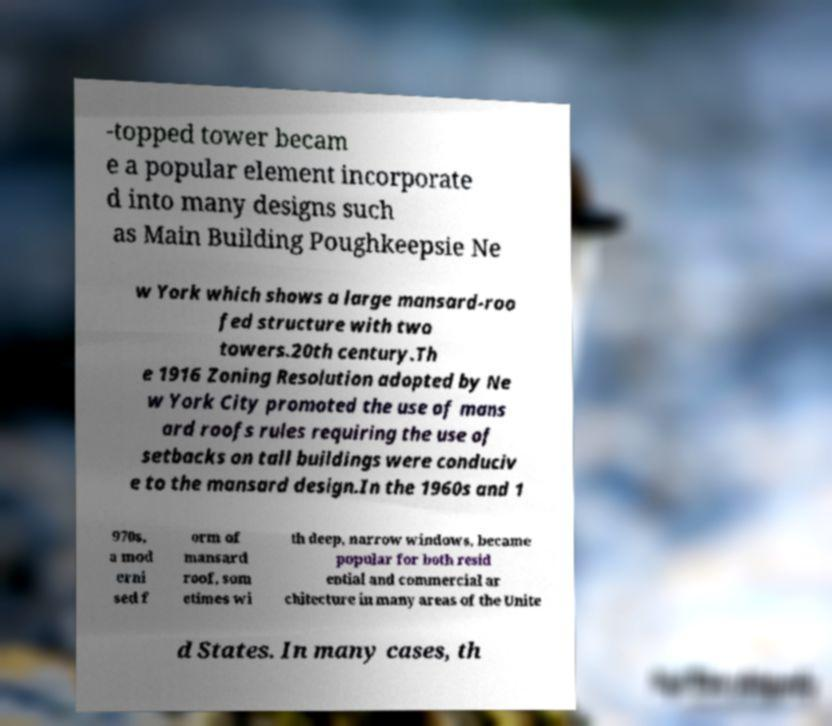Can you accurately transcribe the text from the provided image for me? -topped tower becam e a popular element incorporate d into many designs such as Main Building Poughkeepsie Ne w York which shows a large mansard-roo fed structure with two towers.20th century.Th e 1916 Zoning Resolution adopted by Ne w York City promoted the use of mans ard roofs rules requiring the use of setbacks on tall buildings were conduciv e to the mansard design.In the 1960s and 1 970s, a mod erni sed f orm of mansard roof, som etimes wi th deep, narrow windows, became popular for both resid ential and commercial ar chitecture in many areas of the Unite d States. In many cases, th 